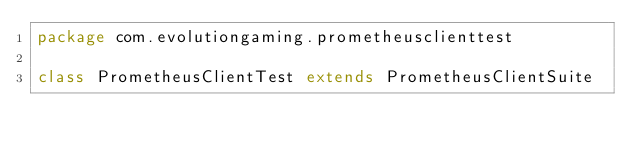Convert code to text. <code><loc_0><loc_0><loc_500><loc_500><_Scala_>package com.evolutiongaming.prometheusclienttest

class PrometheusClientTest extends PrometheusClientSuite</code> 